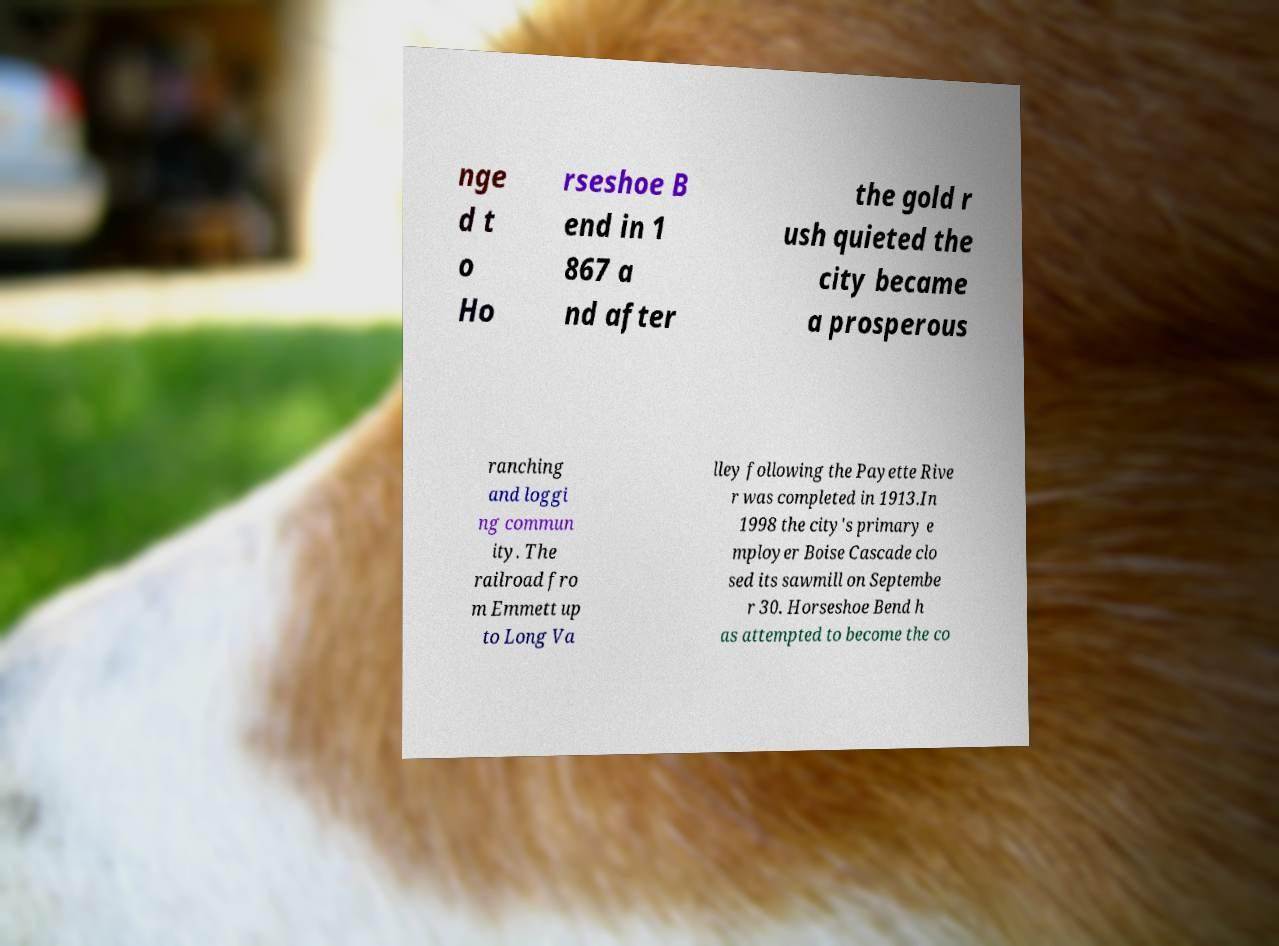Please identify and transcribe the text found in this image. nge d t o Ho rseshoe B end in 1 867 a nd after the gold r ush quieted the city became a prosperous ranching and loggi ng commun ity. The railroad fro m Emmett up to Long Va lley following the Payette Rive r was completed in 1913.In 1998 the city's primary e mployer Boise Cascade clo sed its sawmill on Septembe r 30. Horseshoe Bend h as attempted to become the co 